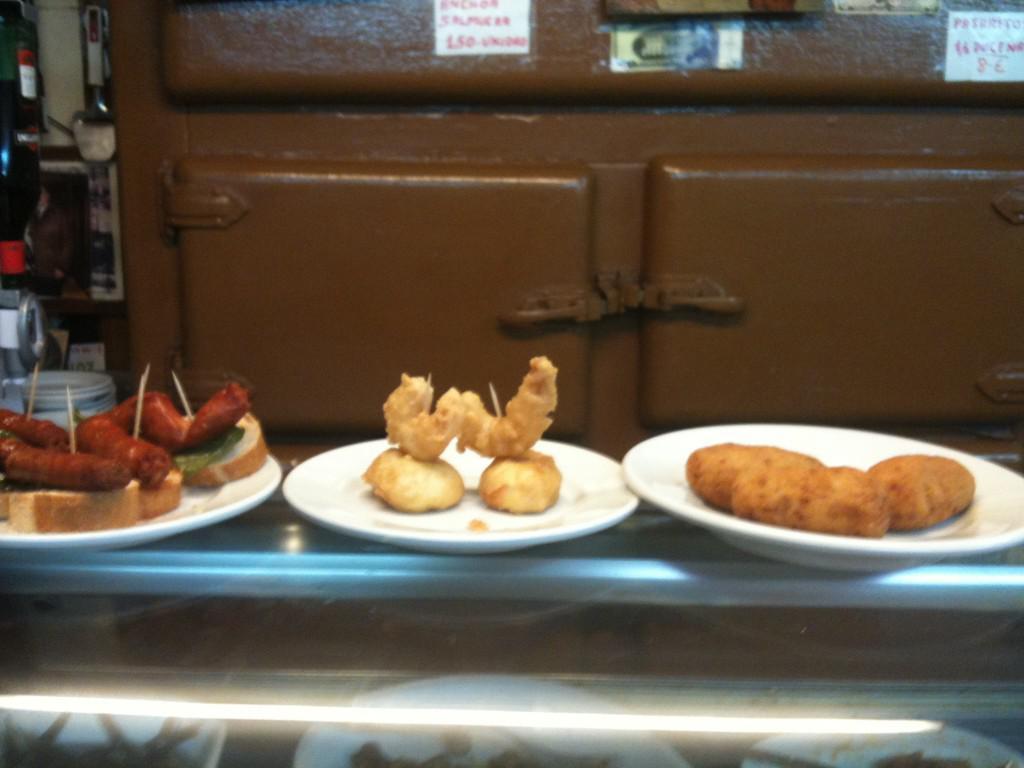In one or two sentences, can you explain what this image depicts? In this image, we can see a few food items in plates are placed on a table. We can see an object in the background. We can also see some posters with text and images. We can also see a bottle and some objects on the left. 